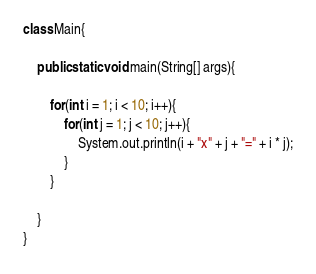Convert code to text. <code><loc_0><loc_0><loc_500><loc_500><_Java_>class Main{

	public static void main(String[] args){

		for(int i = 1; i < 10; i++){
			for(int j = 1; j < 10; j++){
				System.out.println(i + "x" + j + "=" + i * j);
			}
		}

	}
}</code> 